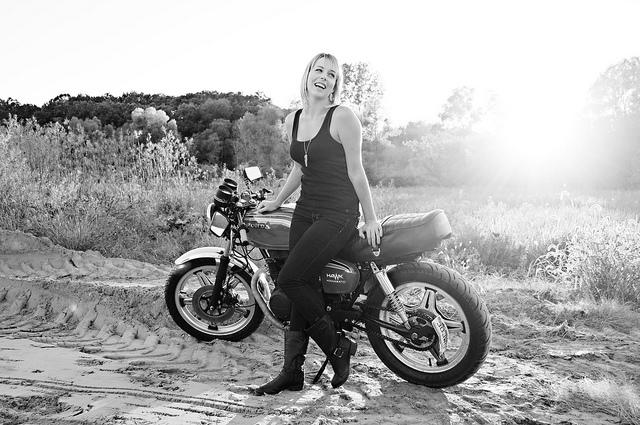Is the photo black and white?
Quick response, please. Yes. Does the woman appear to be happy?
Keep it brief. Yes. What is the woman leaning against?
Answer briefly. Motorcycle. 